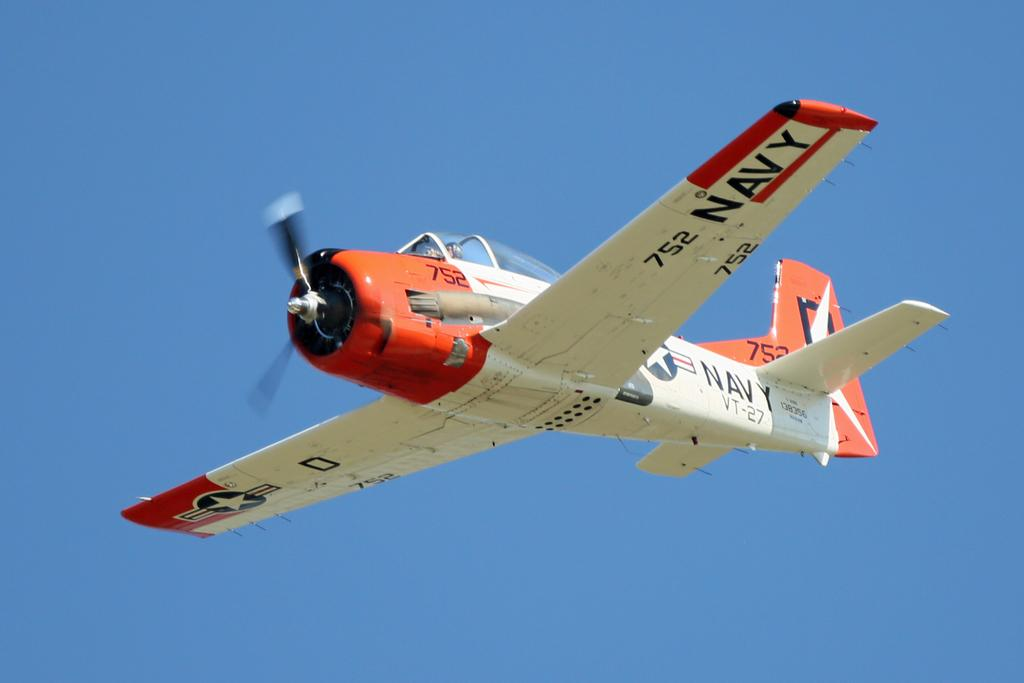<image>
Relay a brief, clear account of the picture shown. An old red and white Navy plane is flying in the blue sky with the number 752 underneath its wing. 